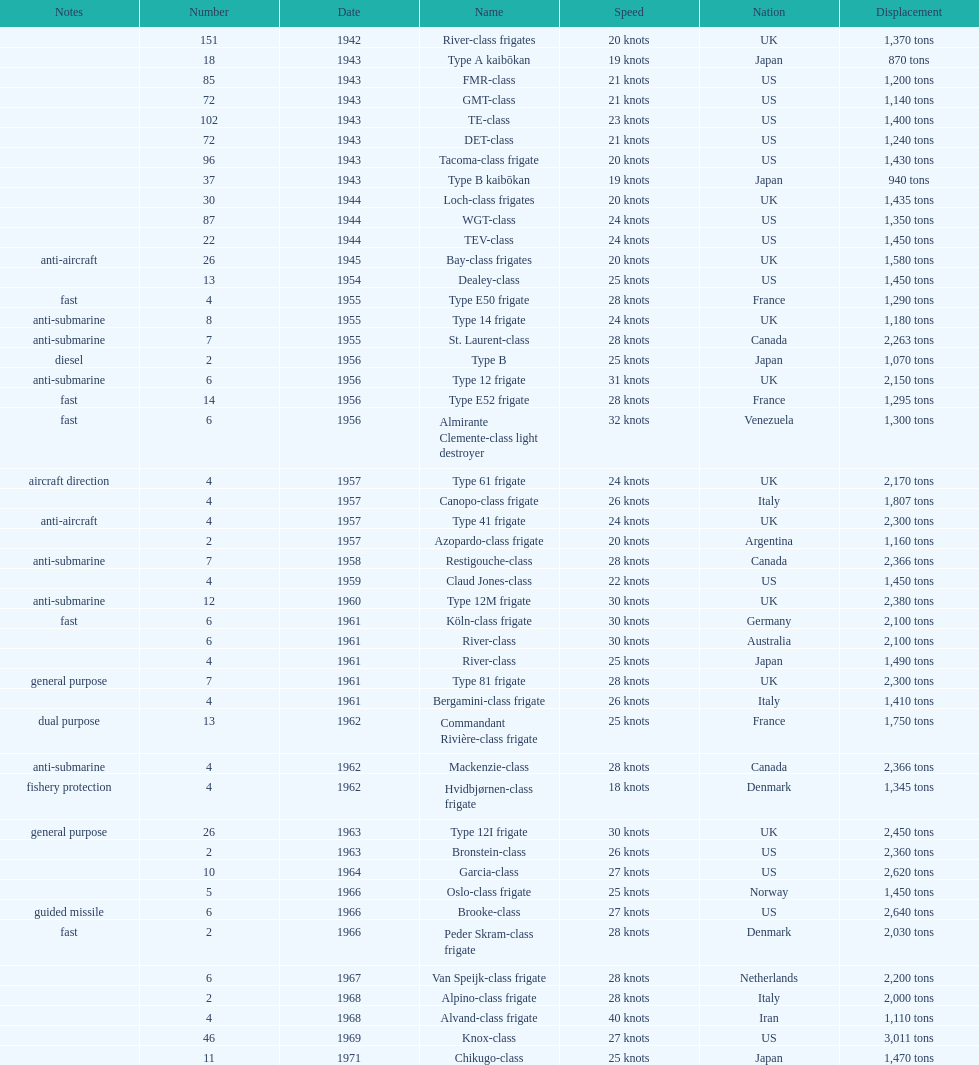What is the difference in speed for the gmt-class and the te-class? 2 knots. 